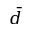Convert formula to latex. <formula><loc_0><loc_0><loc_500><loc_500>\bar { d }</formula> 